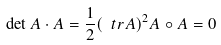Convert formula to latex. <formula><loc_0><loc_0><loc_500><loc_500>\det A \cdot A = \frac { 1 } { 2 } ( \ t r A ) ^ { 2 } A \circ A = 0</formula> 